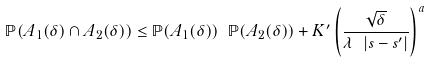<formula> <loc_0><loc_0><loc_500><loc_500>\mathbb { P } ( A _ { 1 } ( \delta ) \cap A _ { 2 } ( \delta ) ) \leq \mathbb { P } ( A _ { 1 } ( \delta ) ) \ \mathbb { P } ( A _ { 2 } ( \delta ) ) + K ^ { \prime } \left ( \frac { \sqrt { \delta } } { \lambda \ | s - s ^ { \prime } | } \right ) ^ { a }</formula> 